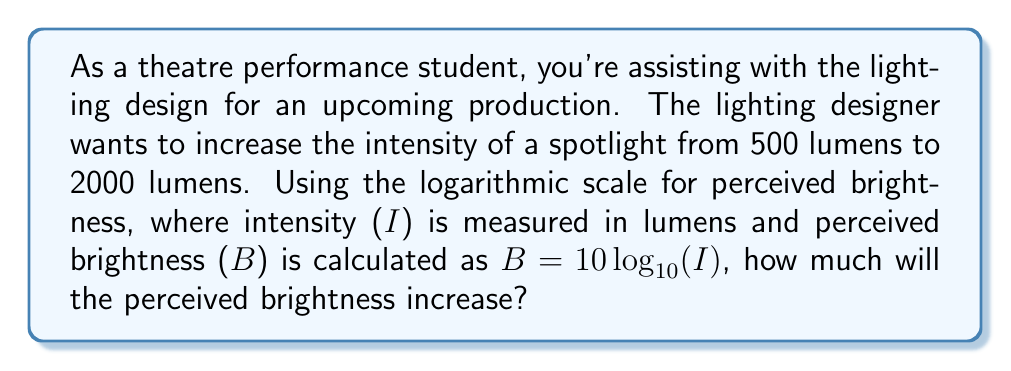Teach me how to tackle this problem. Let's approach this step-by-step:

1) We need to calculate the perceived brightness for both the initial and final intensities using the formula $B = 10 \log_{10}(I)$.

2) For the initial intensity of 500 lumens:
   $B_1 = 10 \log_{10}(500)$
   $B_1 = 10 \cdot 2.69897...$
   $B_1 = 26.9897...$

3) For the final intensity of 2000 lumens:
   $B_2 = 10 \log_{10}(2000)$
   $B_2 = 10 \cdot 3.30103...$
   $B_2 = 33.0103...$

4) To find the increase in perceived brightness, we subtract the initial from the final:
   $\Delta B = B_2 - B_1$
   $\Delta B = 33.0103... - 26.9897...$
   $\Delta B = 6.0206...$

5) Rounding to two decimal places for practical use in lighting design:
   $\Delta B \approx 6.02$

Therefore, the perceived brightness will increase by approximately 6.02 units on the logarithmic scale.
Answer: 6.02 